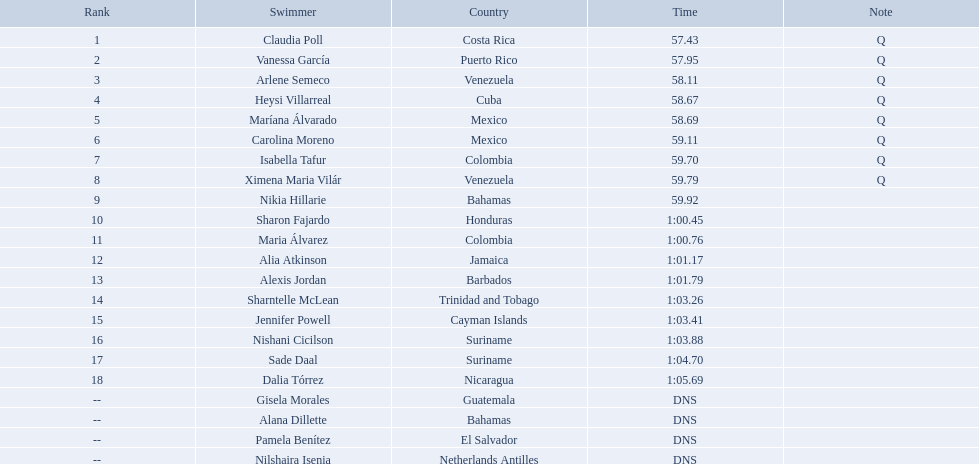Where were the top eight finishers from? Costa Rica, Puerto Rico, Venezuela, Cuba, Mexico, Mexico, Colombia, Venezuela. Which of the top eight were from cuba? Heysi Villarreal. What were the origins of the top eight finishers? Costa Rica, Puerto Rico, Venezuela, Cuba, Mexico, Mexico, Colombia, Venezuela. Which ones from the top eight were cuban? Heysi Villarreal. Who were the competitors in the 2006 central american and caribbean games' women's 100m freestyle swim? Claudia Poll, Vanessa García, Arlene Semeco, Heysi Villarreal, Maríana Álvarado, Carolina Moreno, Isabella Tafur, Ximena Maria Vilár, Nikia Hillarie, Sharon Fajardo, Maria Álvarez, Alia Atkinson, Alexis Jordan, Sharntelle McLean, Jennifer Powell, Nishani Cicilson, Sade Daal, Dalia Tórrez, Gisela Morales, Alana Dillette, Pamela Benítez, Nilshaira Isenia. From this group, who hailed from cuba? Heysi Villarreal. Who were the female participants in the 2006 central american and caribbean games' 100-meter freestyle swimming event? Claudia Poll, Vanessa García, Arlene Semeco, Heysi Villarreal, Maríana Álvarado, Carolina Moreno, Isabella Tafur, Ximena Maria Vilár, Nikia Hillarie, Sharon Fajardo, Maria Álvarez, Alia Atkinson, Alexis Jordan, Sharntelle McLean, Jennifer Powell, Nishani Cicilson, Sade Daal, Dalia Tórrez, Gisela Morales, Alana Dillette, Pamela Benítez, Nilshaira Isenia. Among them, who were from cuba? Heysi Villarreal. What countries did the top eight competitors come from? Costa Rica, Puerto Rico, Venezuela, Cuba, Mexico, Mexico, Colombia, Venezuela. Were any of them from cuba? Heysi Villarreal. 